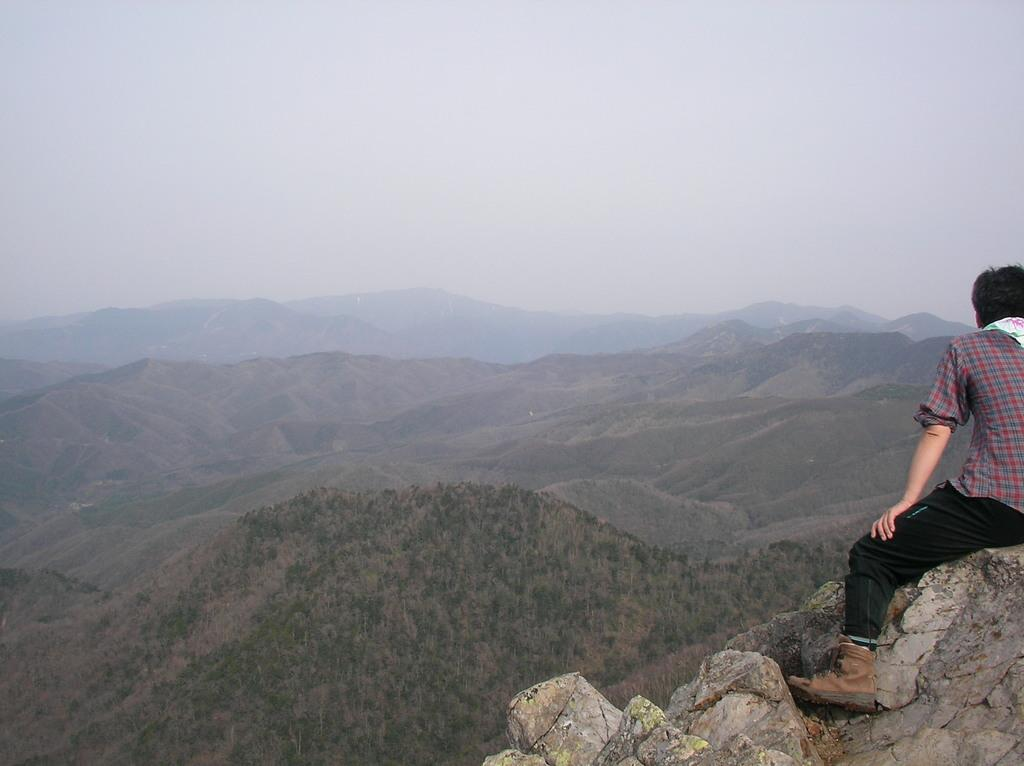What is the person in the image doing? The person is sitting on stones in the image. Where is the person located in relation to the image? The person is in the foreground area of the image. What can be seen in the distance in the image? There are mountains in the background of the image. What is visible above the mountains in the image? The sky is visible in the background of the image. What type of plastic material can be seen covering the mountains in the image? There is no plastic material covering the mountains in the image; the mountains are visible in their natural state. 